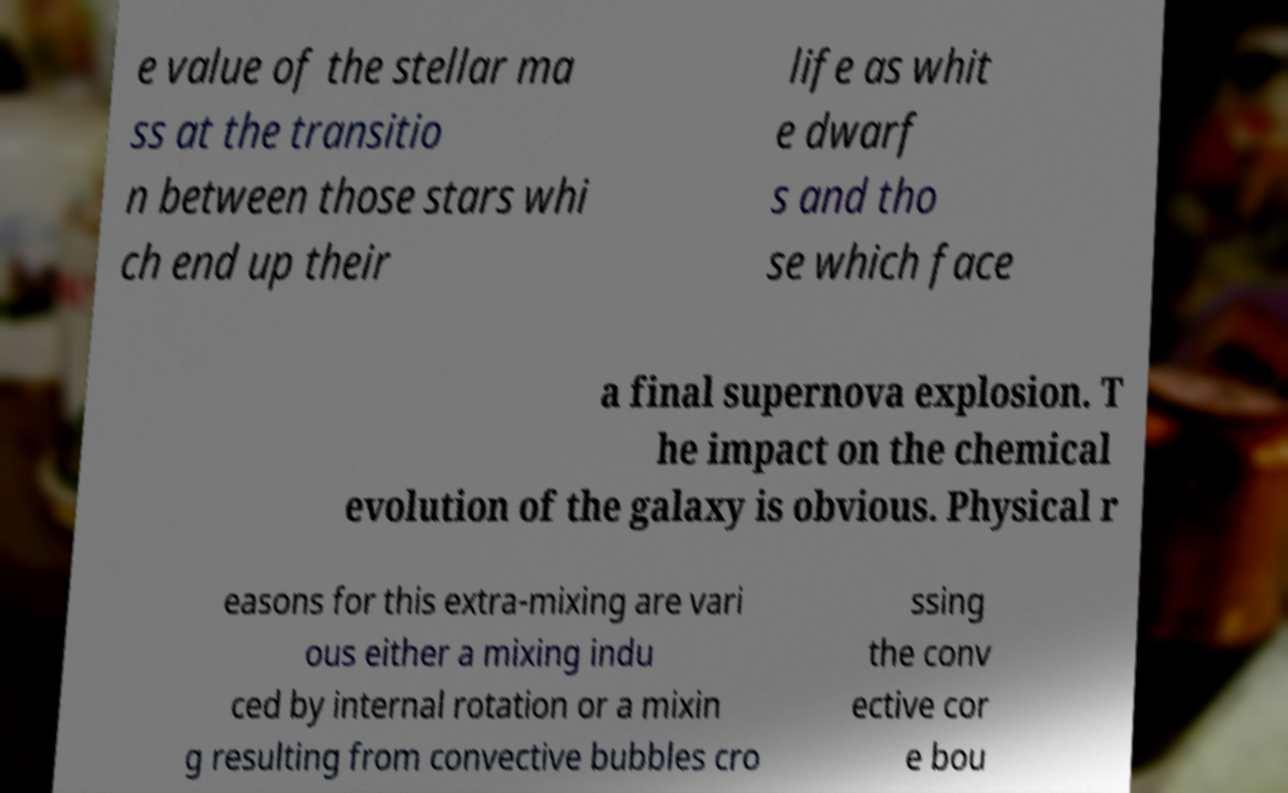What messages or text are displayed in this image? I need them in a readable, typed format. e value of the stellar ma ss at the transitio n between those stars whi ch end up their life as whit e dwarf s and tho se which face a final supernova explosion. T he impact on the chemical evolution of the galaxy is obvious. Physical r easons for this extra-mixing are vari ous either a mixing indu ced by internal rotation or a mixin g resulting from convective bubbles cro ssing the conv ective cor e bou 